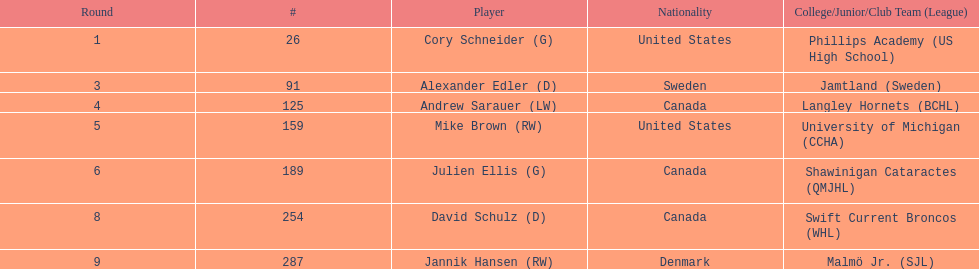Identify the american participants in the list. Cory Schneider (G), Mike Brown (RW). 